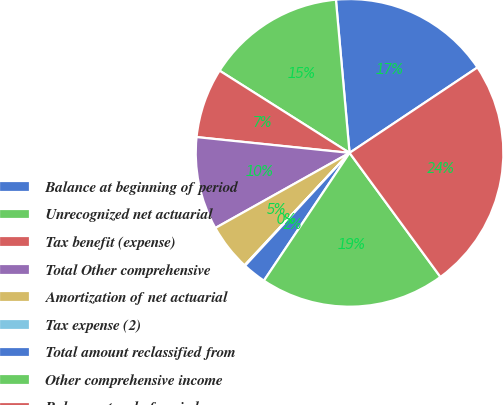<chart> <loc_0><loc_0><loc_500><loc_500><pie_chart><fcel>Balance at beginning of period<fcel>Unrecognized net actuarial<fcel>Tax benefit (expense)<fcel>Total Other comprehensive<fcel>Amortization of net actuarial<fcel>Tax expense (2)<fcel>Total amount reclassified from<fcel>Other comprehensive income<fcel>Balance at end of period<nl><fcel>17.04%<fcel>14.61%<fcel>7.34%<fcel>9.76%<fcel>4.92%<fcel>0.07%<fcel>2.49%<fcel>19.46%<fcel>24.31%<nl></chart> 